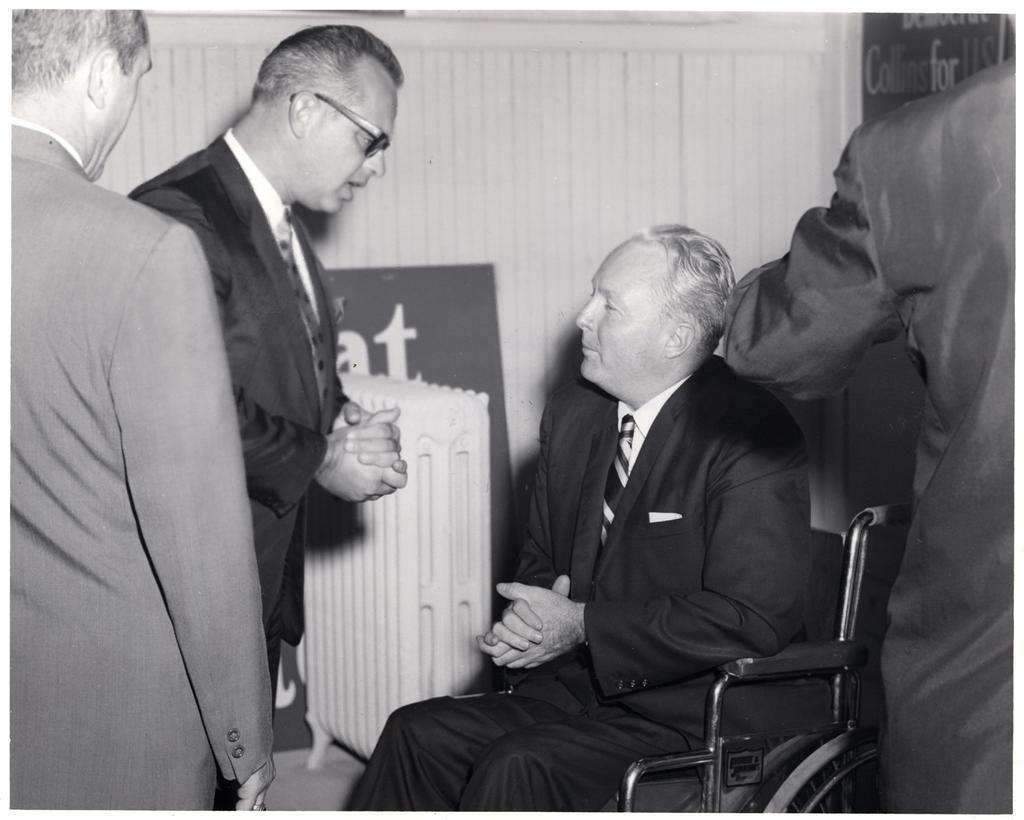Please provide a concise description of this image. This is a black and white picture. Here we can see three persons standing. We can see one man sitting on a wheelchair. This person is talking to this man who is sitting on a wheel chair. 